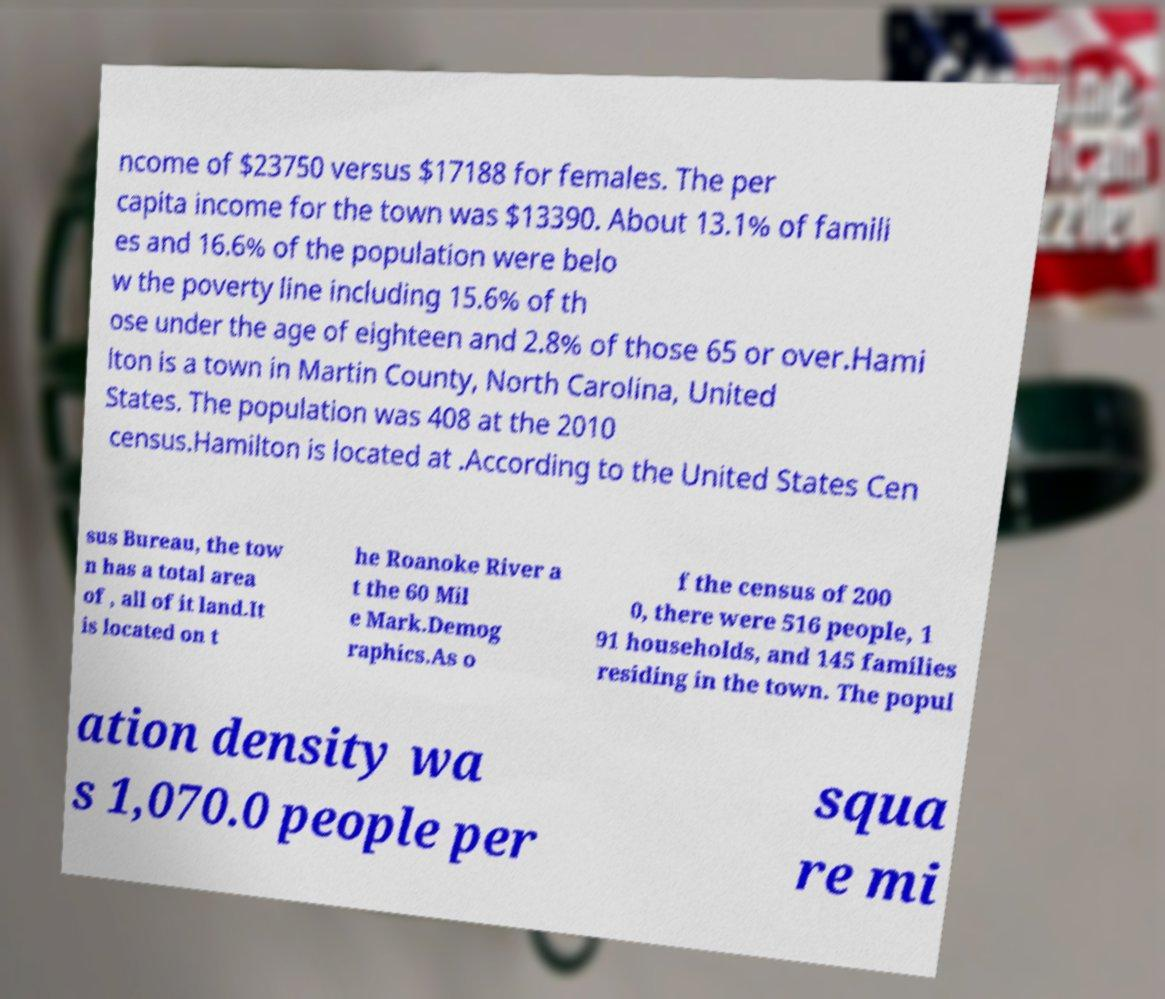Could you extract and type out the text from this image? ncome of $23750 versus $17188 for females. The per capita income for the town was $13390. About 13.1% of famili es and 16.6% of the population were belo w the poverty line including 15.6% of th ose under the age of eighteen and 2.8% of those 65 or over.Hami lton is a town in Martin County, North Carolina, United States. The population was 408 at the 2010 census.Hamilton is located at .According to the United States Cen sus Bureau, the tow n has a total area of , all of it land.It is located on t he Roanoke River a t the 60 Mil e Mark.Demog raphics.As o f the census of 200 0, there were 516 people, 1 91 households, and 145 families residing in the town. The popul ation density wa s 1,070.0 people per squa re mi 